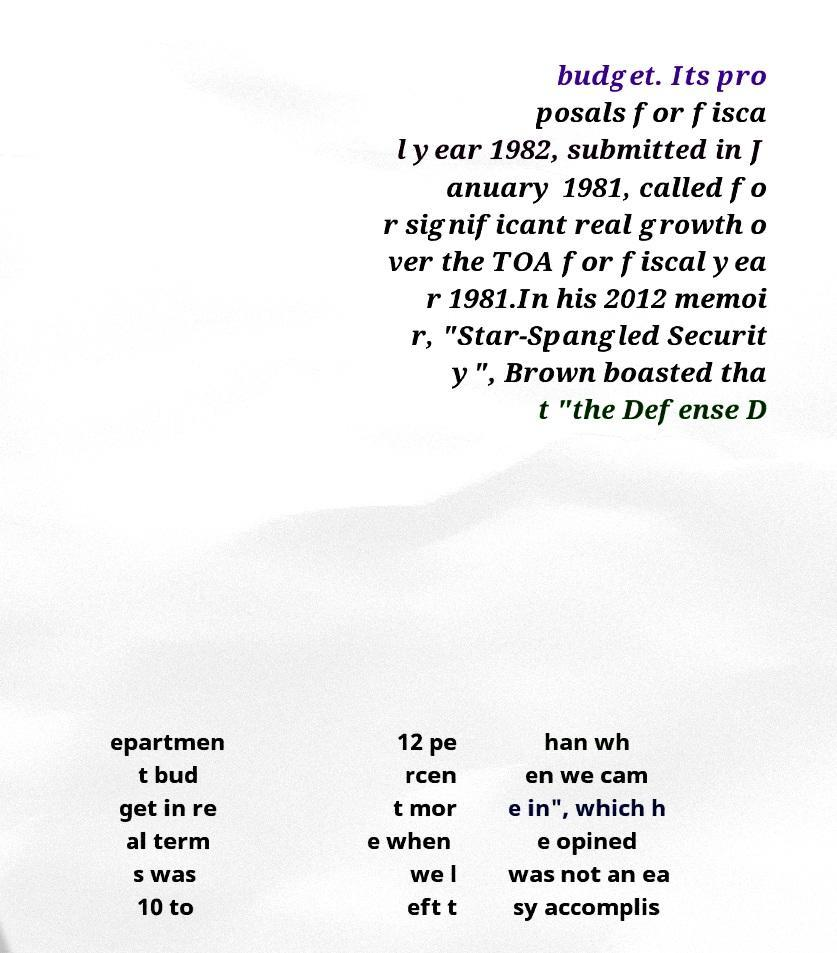Can you accurately transcribe the text from the provided image for me? budget. Its pro posals for fisca l year 1982, submitted in J anuary 1981, called fo r significant real growth o ver the TOA for fiscal yea r 1981.In his 2012 memoi r, "Star-Spangled Securit y", Brown boasted tha t "the Defense D epartmen t bud get in re al term s was 10 to 12 pe rcen t mor e when we l eft t han wh en we cam e in", which h e opined was not an ea sy accomplis 